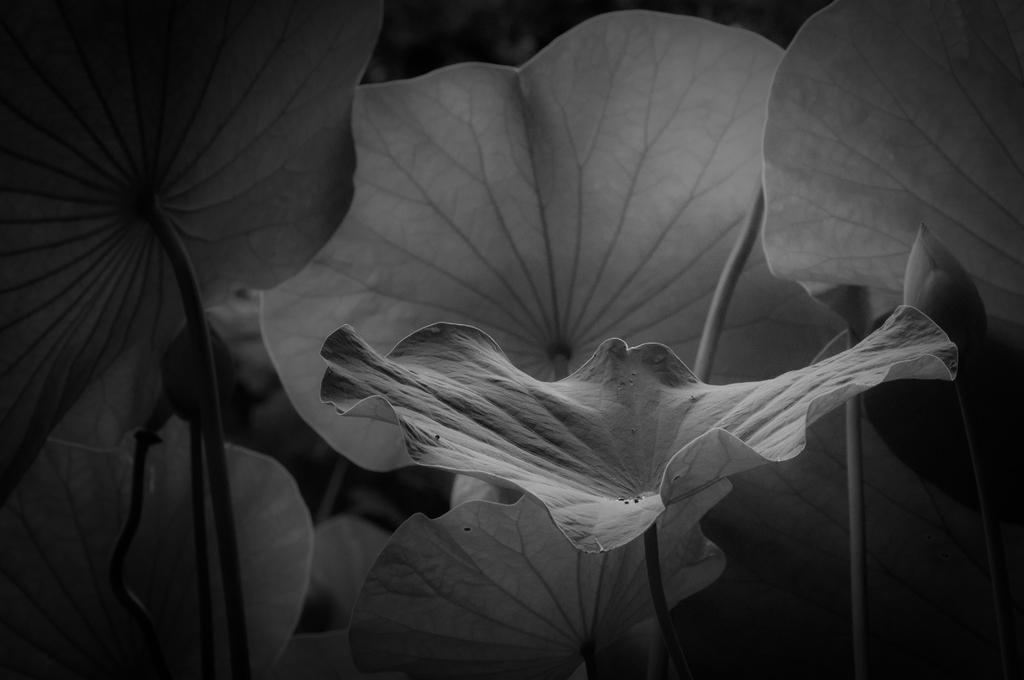What type of vegetation is present at the bottom of the image? There are plants with leaves at the bottom of the image. What can be observed about the background of the image? The background of the image is dark in color. How many pies are visible in the image? There are no pies present in the image. What color is the kitten sitting on the leaves in the image? There is no kitten present in the image. 